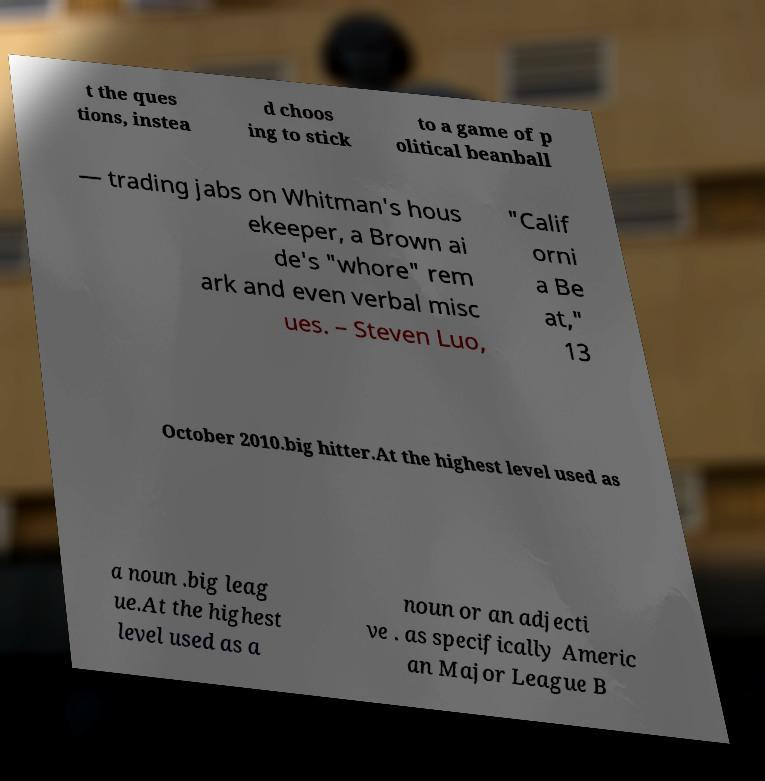There's text embedded in this image that I need extracted. Can you transcribe it verbatim? t the ques tions, instea d choos ing to stick to a game of p olitical beanball — trading jabs on Whitman's hous ekeeper, a Brown ai de's "whore" rem ark and even verbal misc ues. – Steven Luo, "Calif orni a Be at," 13 October 2010.big hitter.At the highest level used as a noun .big leag ue.At the highest level used as a noun or an adjecti ve . as specifically Americ an Major League B 